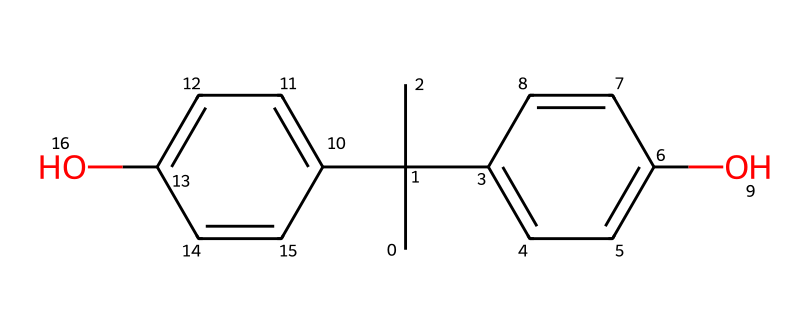How many hydroxyl (–OH) groups are present in bisphenol A? The structure indicates two distinct phenolic rings, each containing one hydroxyl group. Therefore, by counting the –OH groups in the structure, we find there are two.
Answer: 2 What functional group is present in bisphenol A? The hydroxyl (–OH) groups on the phenolic rings indicate that bisphenol A contains phenolic functional groups characteristic of phenols.
Answer: hydroxyl What is the total number of carbon atoms in bisphenol A? By analyzing the structure, there are 15 carbon atoms counted in the two phenolic rings and the branched structure. Therefore, the total adds up to 15.
Answer: 15 Does bisphenol A contain any aromatic rings? The structure shows that there are two phenolic (aromatic) rings interconnected. This confirms the presence of aromatic characteristics in bisphenol A.
Answer: yes What is the primary use of bisphenol A in e-reader screens? Bisphenol A is primarily used in the production of polycarbonate plastics, which are known for their durability and optical clarity, making them suitable for e-reader screens.
Answer: coating 